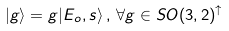<formula> <loc_0><loc_0><loc_500><loc_500>| g \rangle = g | E _ { o } , s \rangle \, , \, \forall g \in S O ( 3 , 2 ) ^ { \uparrow }</formula> 